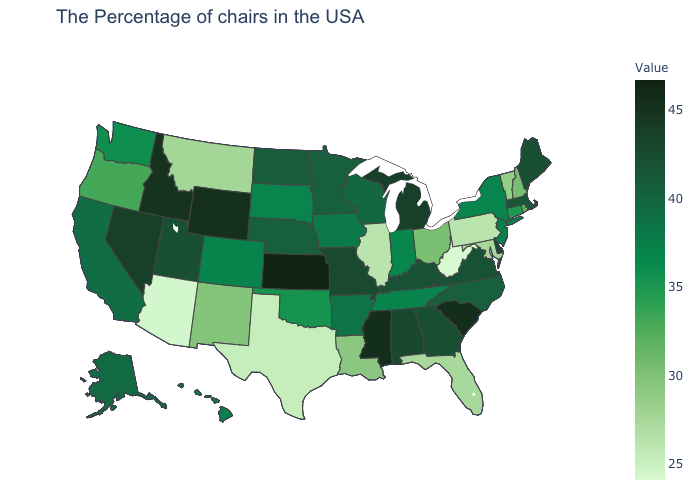Among the states that border Nevada , which have the lowest value?
Short answer required. Arizona. Which states have the lowest value in the USA?
Give a very brief answer. West Virginia. Which states have the lowest value in the South?
Answer briefly. West Virginia. Which states have the lowest value in the South?
Concise answer only. West Virginia. Does West Virginia have the lowest value in the USA?
Short answer required. Yes. 